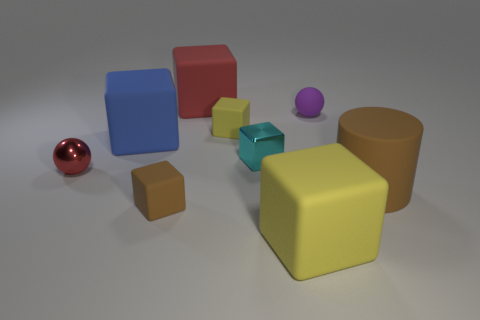Is there anything else that has the same material as the big yellow object?
Offer a terse response. Yes. Is there any other thing that has the same color as the metallic cube?
Offer a terse response. No. There is a brown cylinder that is the same size as the blue thing; what material is it?
Your answer should be compact. Rubber. There is a blue matte block on the left side of the cylinder; what size is it?
Keep it short and to the point. Large. Is the size of the yellow matte thing behind the big cylinder the same as the brown object that is in front of the large cylinder?
Offer a very short reply. Yes. How many other brown cylinders are made of the same material as the large cylinder?
Your answer should be very brief. 0. What color is the large cylinder?
Provide a short and direct response. Brown. Are there any small balls in front of the tiny cyan cube?
Offer a terse response. Yes. What number of matte objects are the same color as the rubber cylinder?
Your answer should be compact. 1. There is a purple object right of the metallic thing on the left side of the small cyan block; how big is it?
Offer a very short reply. Small. 